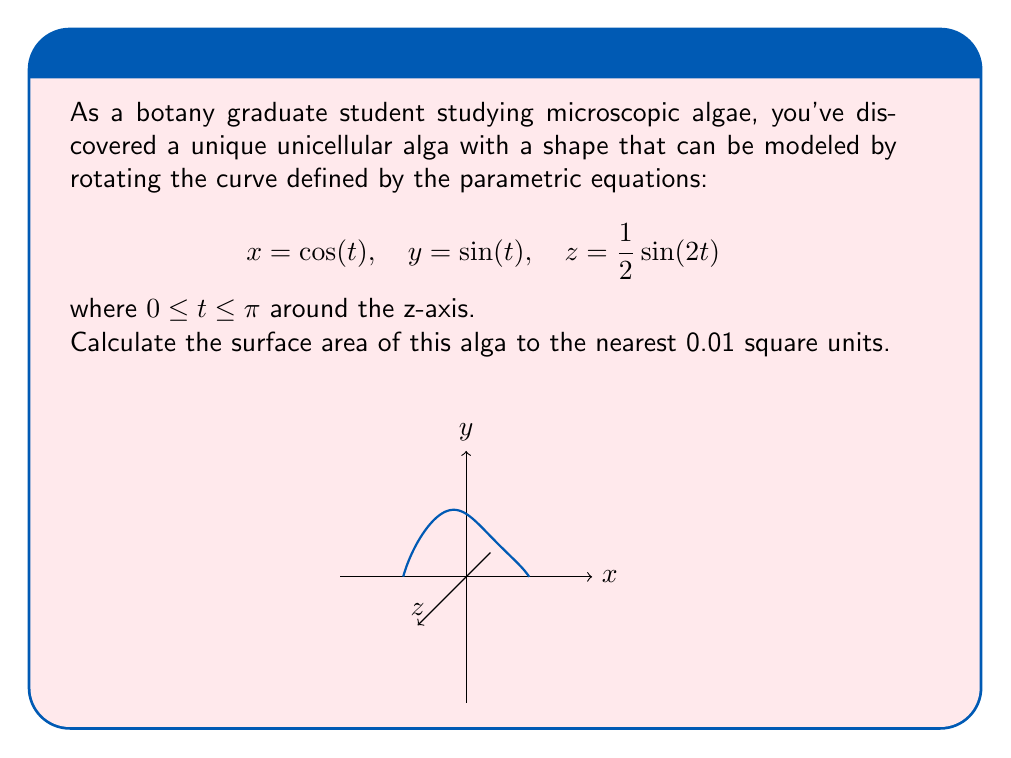Help me with this question. To calculate the surface area, we'll use the surface area formula for parametric equations rotated around the z-axis:

$$A = 2\pi \int_a^b f(t) \sqrt{\left(\frac{dx}{dt}\right)^2 + \left(\frac{dy}{dt}\right)^2 + \left(\frac{dz}{dt}\right)^2} dt$$

Where $f(t)$ is the distance from the z-axis, which in this case is $\sqrt{x^2 + y^2} = \sqrt{\cos^2(t) + \sin^2(t)} = 1$.

Step 1: Calculate the derivatives:
$$\frac{dx}{dt} = -\sin(t)$$
$$\frac{dy}{dt} = \cos(t)$$
$$\frac{dz}{dt} = \cos(2t)$$

Step 2: Substitute into the formula:
$$A = 2\pi \int_0^\pi 1 \cdot \sqrt{(-\sin(t))^2 + (\cos(t))^2 + (\cos(2t))^2} dt$$

Step 3: Simplify under the square root:
$$A = 2\pi \int_0^\pi \sqrt{\sin^2(t) + \cos^2(t) + \cos^2(2t)} dt$$
$$A = 2\pi \int_0^\pi \sqrt{1 + \cos^2(2t)} dt$$

Step 4: This integral doesn't have an elementary antiderivative, so we need to use numerical integration. Using a computer algebra system or numerical integration tool, we get:

$$A \approx 2\pi \cdot 1.2112 \approx 7.6146$$

Step 5: Rounding to the nearest 0.01:
$$A \approx 7.61 \text{ square units}$$
Answer: $7.61 \text{ square units}$ 